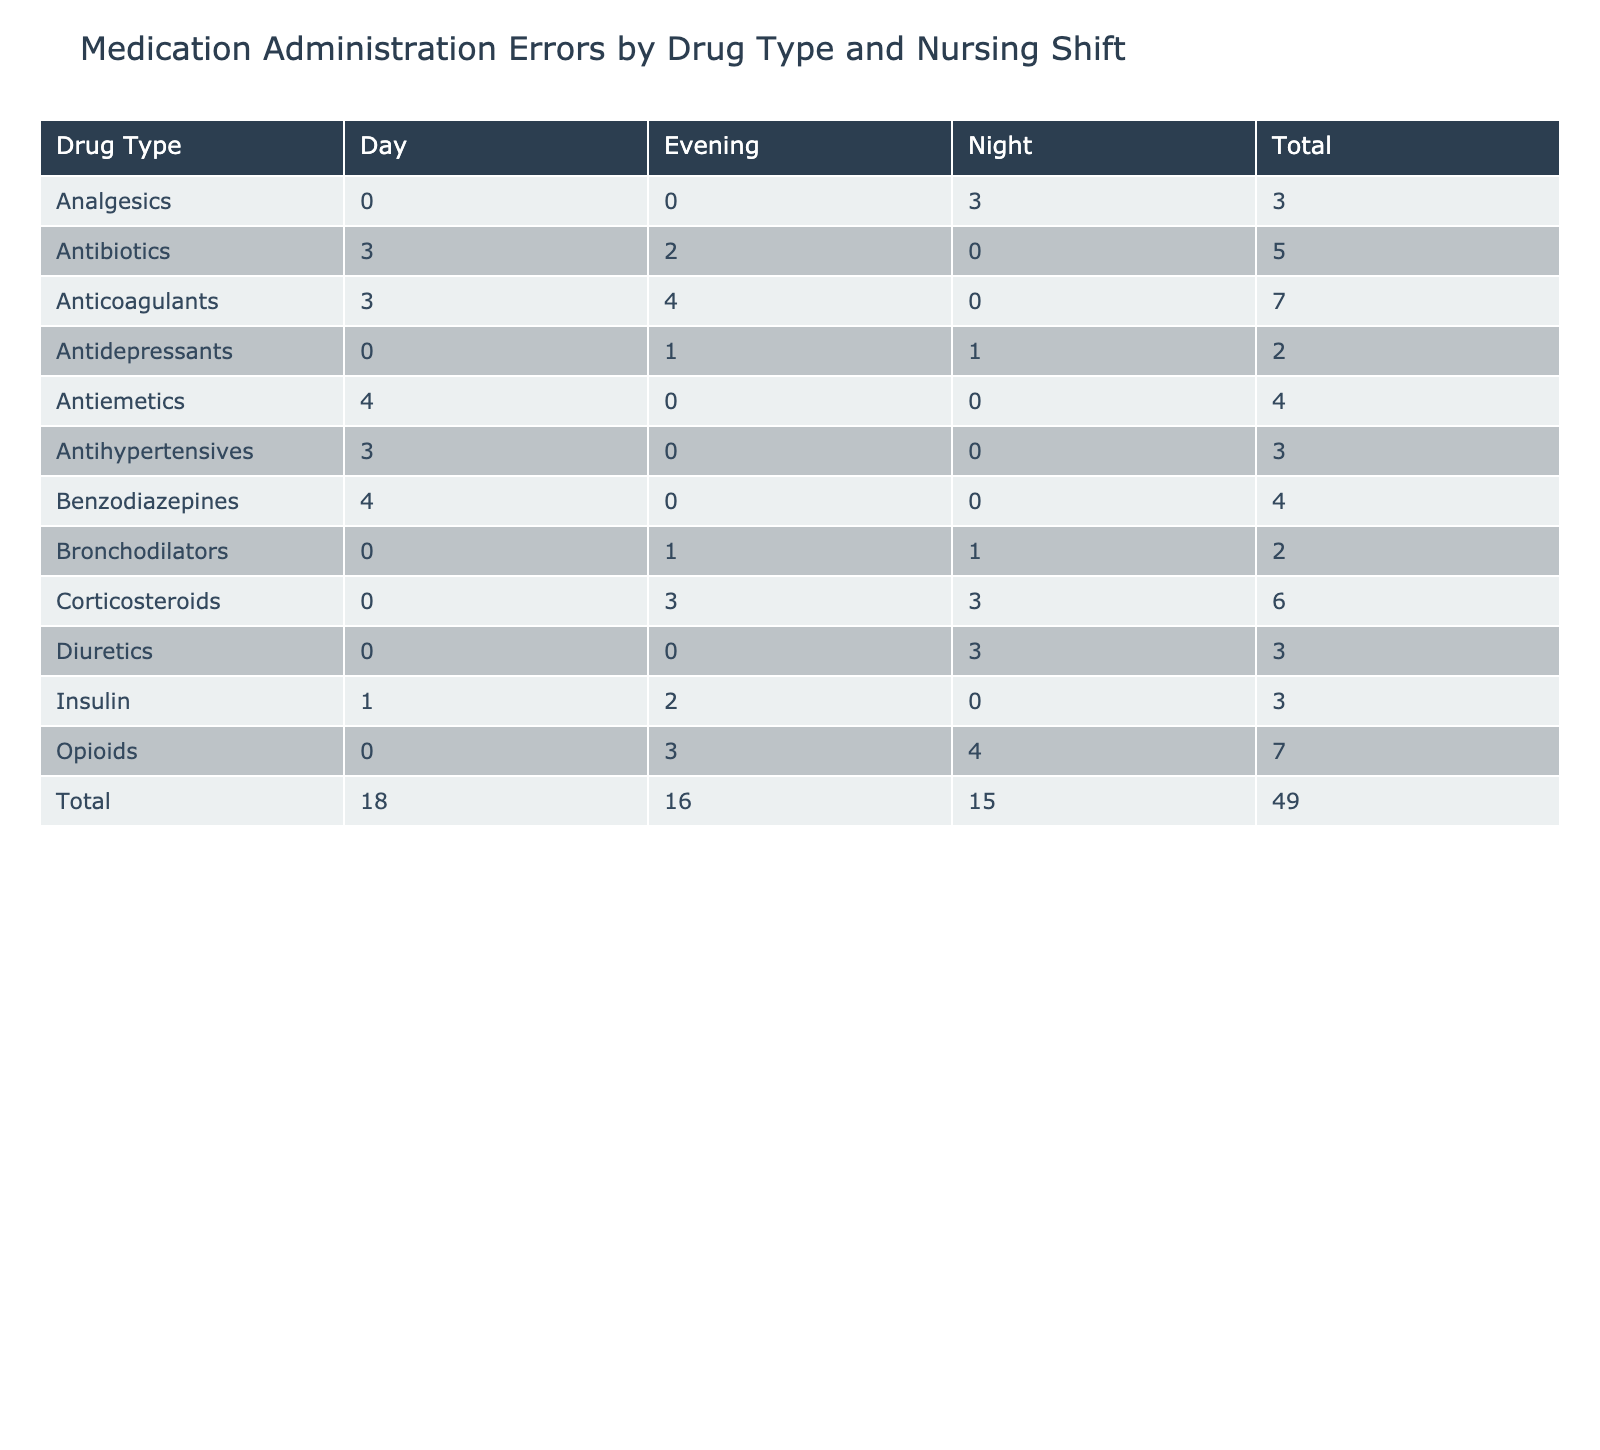What is the total number of medication administration errors for Opioids during the Night shift? To find the total errors for Opioids during the Night shift, look at the 'Opioids' row and find the value under the 'Night' column. This value is 4.
Answer: 4 Which nursing shift has the highest number of errors for Antibiotics? Checking the rows corresponding to 'Antibiotics', the counts are: Day (3), Evening (2). The highest count is for the Day shift with a total of 3 errors.
Answer: Day What is the combined total count of errors for Diuretics across all nursing shifts? The counts for Diuretics are: Night (2), Night (1). Adding these counts gives a total of 2 + 1 = 3.
Answer: 3 Did any Nursing Shift report an Omission error for Anticoagulants? Reviewing the table, the Anticoagulants row shows no entries for Omission under any of the three shifts. Therefore, the answer is no.
Answer: No What is the difference in total errors between the Day and Night shifts? To find the total errors for each shift, sum across all drug types for Day (3 + 1 + 1 + 2 + 3 + 2 = 12) and Night (2 + 1 + 3 + 4 + 1 + 3 = 14). The difference is 14 - 12 = 2.
Answer: 2 Which drug type has the most errors during the Evening shift? Inspecting the Evening shift column, the counts are: Anticoagulants (4), Opioids (3), Bronchodilators (1). Anticoagulants has the highest count with 4 errors.
Answer: Anticoagulants How many errors were reported for Wrong Route under any drug type during the Day shift? From the Day shift column, the drug types with Wrong Route errors are: Antihypertensives (1), Benzodiazepines (2). Summing these gives a total of 1 + 2 = 3 errors.
Answer: 3 Was there any drug type that had a Wrong Patient error during the Day shift? Reviewing the Day shift column for Wrong Patient errors, there are no entries, confirming that no drug type reported this error during that shift.
Answer: No What is the average number of errors for Antidepressants across all shifts? The counts for Antidepressants are: Night (1), Evening (1), resulting in a total of 1 + 1 = 2 errors. The average is then calculated by dividing by the number of shifts (2), giving an average of 2/2 = 1.
Answer: 1 